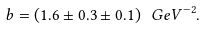<formula> <loc_0><loc_0><loc_500><loc_500>b = \left ( 1 . 6 \pm 0 . 3 \pm 0 . 1 \right ) { \ G e V } ^ { - 2 } .</formula> 